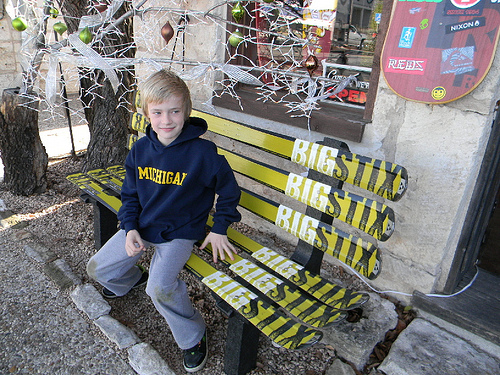<image>
Is there a shoe under the tree? No. The shoe is not positioned under the tree. The vertical relationship between these objects is different. Is there a tree in front of the boy? No. The tree is not in front of the boy. The spatial positioning shows a different relationship between these objects. Is the michigan above the bench? Yes. The michigan is positioned above the bench in the vertical space, higher up in the scene. 